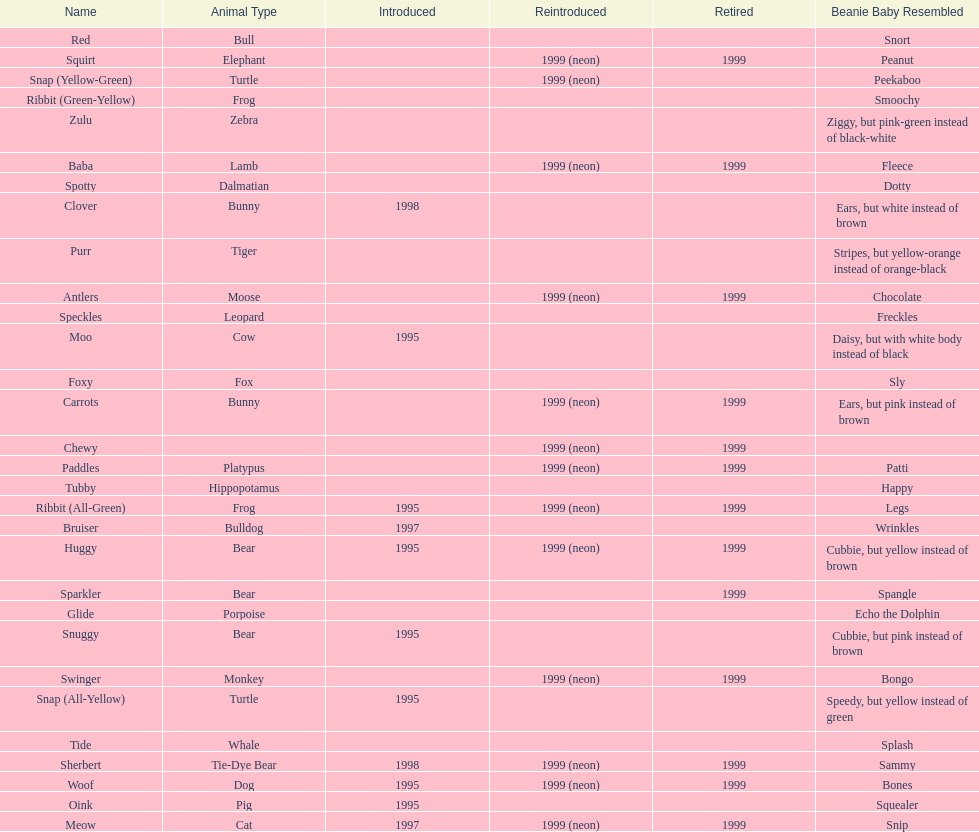What is the name of the pillow pal listed after clover? Foxy. 